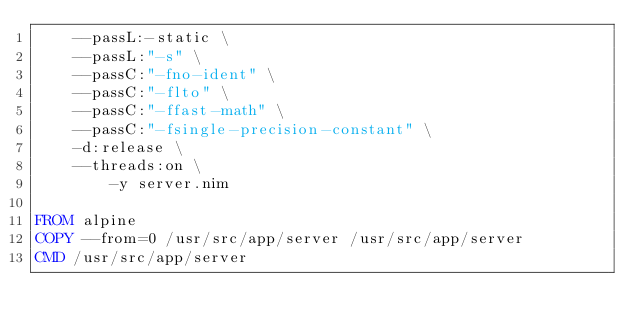<code> <loc_0><loc_0><loc_500><loc_500><_Dockerfile_>    --passL:-static \
    --passL:"-s" \
    --passC:"-fno-ident" \
    --passC:"-flto" \
    --passC:"-ffast-math" \
    --passC:"-fsingle-precision-constant" \
    -d:release \
    --threads:on \
        -y server.nim

FROM alpine
COPY --from=0 /usr/src/app/server /usr/src/app/server
CMD /usr/src/app/server
</code> 